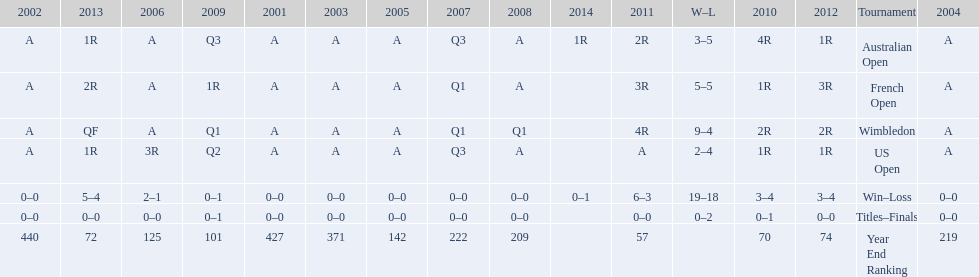Which years was a ranking below 200 achieved? 2005, 2006, 2009, 2010, 2011, 2012, 2013. 